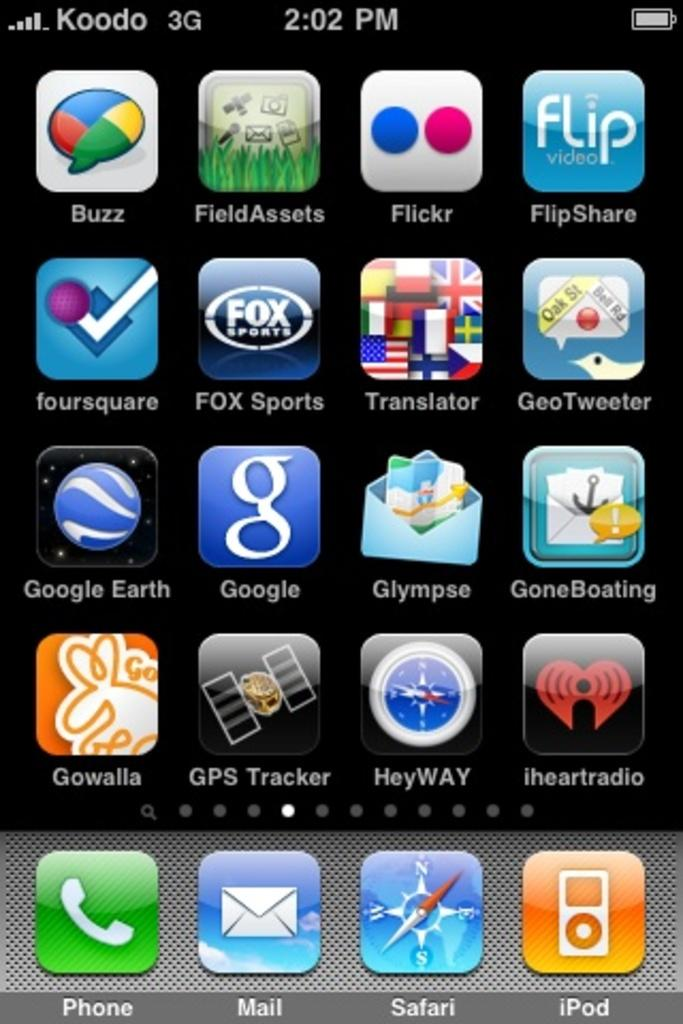<image>
Describe the image concisely. The iPhone has many apps such as Google Earth and Safari. 